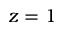Convert formula to latex. <formula><loc_0><loc_0><loc_500><loc_500>z = 1</formula> 